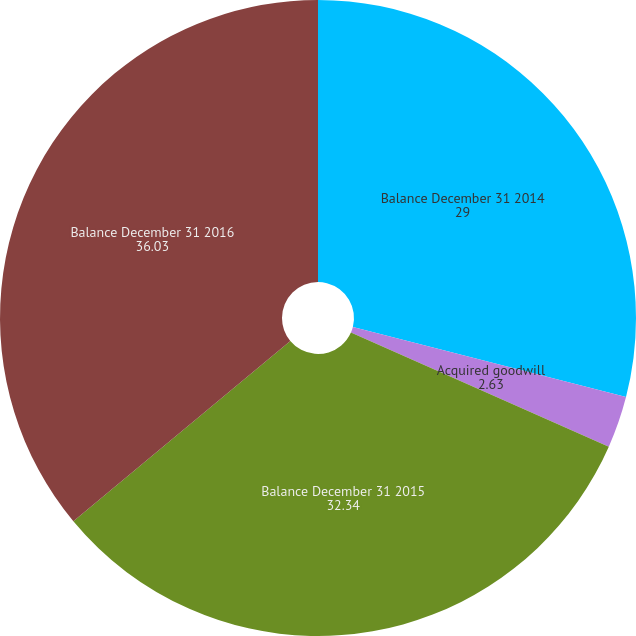<chart> <loc_0><loc_0><loc_500><loc_500><pie_chart><fcel>Balance December 31 2014<fcel>Acquired goodwill<fcel>Balance December 31 2015<fcel>Balance December 31 2016<nl><fcel>29.0%<fcel>2.63%<fcel>32.34%<fcel>36.03%<nl></chart> 